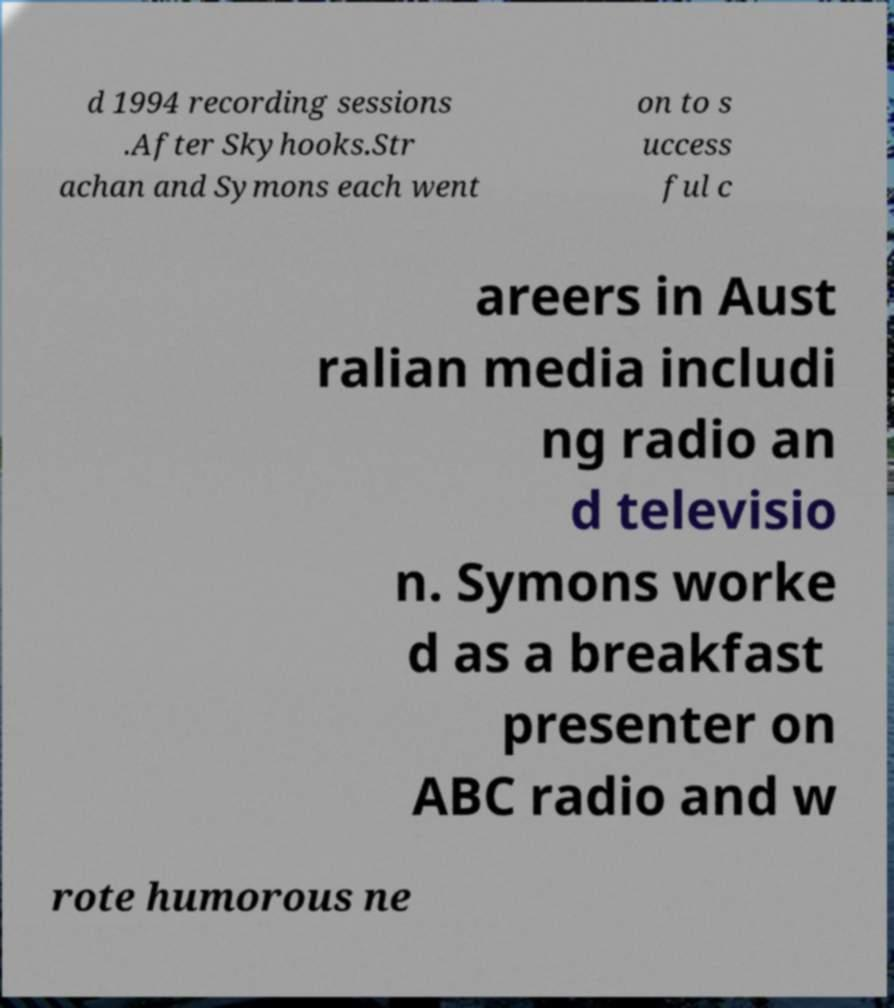Can you accurately transcribe the text from the provided image for me? d 1994 recording sessions .After Skyhooks.Str achan and Symons each went on to s uccess ful c areers in Aust ralian media includi ng radio an d televisio n. Symons worke d as a breakfast presenter on ABC radio and w rote humorous ne 